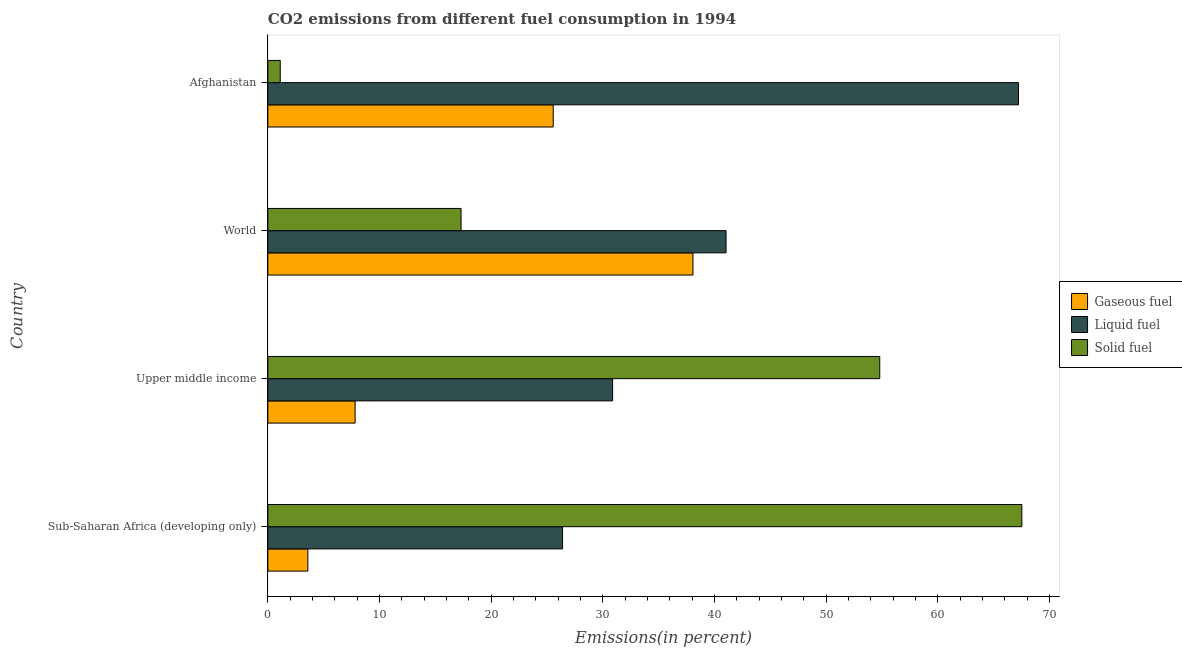How many different coloured bars are there?
Provide a short and direct response. 3. How many bars are there on the 2nd tick from the top?
Keep it short and to the point. 3. What is the label of the 4th group of bars from the top?
Offer a very short reply. Sub-Saharan Africa (developing only). What is the percentage of solid fuel emission in Upper middle income?
Provide a succinct answer. 54.8. Across all countries, what is the maximum percentage of solid fuel emission?
Provide a short and direct response. 67.52. Across all countries, what is the minimum percentage of gaseous fuel emission?
Offer a very short reply. 3.58. In which country was the percentage of liquid fuel emission maximum?
Offer a terse response. Afghanistan. In which country was the percentage of gaseous fuel emission minimum?
Give a very brief answer. Sub-Saharan Africa (developing only). What is the total percentage of gaseous fuel emission in the graph?
Your answer should be very brief. 75.02. What is the difference between the percentage of liquid fuel emission in Afghanistan and that in Sub-Saharan Africa (developing only)?
Your answer should be very brief. 40.83. What is the difference between the percentage of gaseous fuel emission in Sub-Saharan Africa (developing only) and the percentage of solid fuel emission in Afghanistan?
Your response must be concise. 2.47. What is the average percentage of liquid fuel emission per country?
Give a very brief answer. 41.38. What is the difference between the percentage of liquid fuel emission and percentage of gaseous fuel emission in Upper middle income?
Offer a terse response. 23.06. In how many countries, is the percentage of liquid fuel emission greater than 68 %?
Offer a very short reply. 0. What is the ratio of the percentage of gaseous fuel emission in Afghanistan to that in World?
Your answer should be compact. 0.67. Is the percentage of solid fuel emission in Sub-Saharan Africa (developing only) less than that in World?
Keep it short and to the point. No. Is the difference between the percentage of liquid fuel emission in Afghanistan and World greater than the difference between the percentage of gaseous fuel emission in Afghanistan and World?
Offer a very short reply. Yes. What is the difference between the highest and the second highest percentage of solid fuel emission?
Your response must be concise. 12.72. What is the difference between the highest and the lowest percentage of solid fuel emission?
Your answer should be compact. 66.41. In how many countries, is the percentage of gaseous fuel emission greater than the average percentage of gaseous fuel emission taken over all countries?
Ensure brevity in your answer.  2. Is the sum of the percentage of solid fuel emission in Afghanistan and Sub-Saharan Africa (developing only) greater than the maximum percentage of gaseous fuel emission across all countries?
Offer a terse response. Yes. What does the 3rd bar from the top in Upper middle income represents?
Make the answer very short. Gaseous fuel. What does the 3rd bar from the bottom in Upper middle income represents?
Make the answer very short. Solid fuel. Is it the case that in every country, the sum of the percentage of gaseous fuel emission and percentage of liquid fuel emission is greater than the percentage of solid fuel emission?
Make the answer very short. No. Are all the bars in the graph horizontal?
Your response must be concise. Yes. Where does the legend appear in the graph?
Keep it short and to the point. Center right. How many legend labels are there?
Provide a short and direct response. 3. What is the title of the graph?
Your answer should be compact. CO2 emissions from different fuel consumption in 1994. Does "Female employers" appear as one of the legend labels in the graph?
Your response must be concise. No. What is the label or title of the X-axis?
Offer a very short reply. Emissions(in percent). What is the Emissions(in percent) in Gaseous fuel in Sub-Saharan Africa (developing only)?
Offer a terse response. 3.58. What is the Emissions(in percent) in Liquid fuel in Sub-Saharan Africa (developing only)?
Your answer should be very brief. 26.39. What is the Emissions(in percent) in Solid fuel in Sub-Saharan Africa (developing only)?
Your answer should be compact. 67.52. What is the Emissions(in percent) in Gaseous fuel in Upper middle income?
Give a very brief answer. 7.81. What is the Emissions(in percent) of Liquid fuel in Upper middle income?
Ensure brevity in your answer.  30.88. What is the Emissions(in percent) of Solid fuel in Upper middle income?
Provide a succinct answer. 54.8. What is the Emissions(in percent) in Gaseous fuel in World?
Keep it short and to the point. 38.07. What is the Emissions(in percent) of Liquid fuel in World?
Ensure brevity in your answer.  41.03. What is the Emissions(in percent) in Solid fuel in World?
Provide a succinct answer. 17.3. What is the Emissions(in percent) in Gaseous fuel in Afghanistan?
Provide a short and direct response. 25.56. What is the Emissions(in percent) in Liquid fuel in Afghanistan?
Ensure brevity in your answer.  67.22. What is the Emissions(in percent) of Solid fuel in Afghanistan?
Give a very brief answer. 1.11. Across all countries, what is the maximum Emissions(in percent) of Gaseous fuel?
Offer a terse response. 38.07. Across all countries, what is the maximum Emissions(in percent) in Liquid fuel?
Ensure brevity in your answer.  67.22. Across all countries, what is the maximum Emissions(in percent) in Solid fuel?
Make the answer very short. 67.52. Across all countries, what is the minimum Emissions(in percent) in Gaseous fuel?
Offer a very short reply. 3.58. Across all countries, what is the minimum Emissions(in percent) in Liquid fuel?
Your response must be concise. 26.39. Across all countries, what is the minimum Emissions(in percent) in Solid fuel?
Provide a succinct answer. 1.11. What is the total Emissions(in percent) of Gaseous fuel in the graph?
Ensure brevity in your answer.  75.02. What is the total Emissions(in percent) in Liquid fuel in the graph?
Keep it short and to the point. 165.52. What is the total Emissions(in percent) in Solid fuel in the graph?
Your response must be concise. 140.73. What is the difference between the Emissions(in percent) in Gaseous fuel in Sub-Saharan Africa (developing only) and that in Upper middle income?
Your answer should be compact. -4.23. What is the difference between the Emissions(in percent) of Liquid fuel in Sub-Saharan Africa (developing only) and that in Upper middle income?
Provide a succinct answer. -4.48. What is the difference between the Emissions(in percent) in Solid fuel in Sub-Saharan Africa (developing only) and that in Upper middle income?
Provide a short and direct response. 12.72. What is the difference between the Emissions(in percent) in Gaseous fuel in Sub-Saharan Africa (developing only) and that in World?
Keep it short and to the point. -34.49. What is the difference between the Emissions(in percent) of Liquid fuel in Sub-Saharan Africa (developing only) and that in World?
Keep it short and to the point. -14.64. What is the difference between the Emissions(in percent) in Solid fuel in Sub-Saharan Africa (developing only) and that in World?
Provide a short and direct response. 50.22. What is the difference between the Emissions(in percent) of Gaseous fuel in Sub-Saharan Africa (developing only) and that in Afghanistan?
Give a very brief answer. -21.97. What is the difference between the Emissions(in percent) in Liquid fuel in Sub-Saharan Africa (developing only) and that in Afghanistan?
Ensure brevity in your answer.  -40.83. What is the difference between the Emissions(in percent) in Solid fuel in Sub-Saharan Africa (developing only) and that in Afghanistan?
Offer a terse response. 66.41. What is the difference between the Emissions(in percent) of Gaseous fuel in Upper middle income and that in World?
Give a very brief answer. -30.26. What is the difference between the Emissions(in percent) in Liquid fuel in Upper middle income and that in World?
Your answer should be compact. -10.16. What is the difference between the Emissions(in percent) in Solid fuel in Upper middle income and that in World?
Ensure brevity in your answer.  37.49. What is the difference between the Emissions(in percent) of Gaseous fuel in Upper middle income and that in Afghanistan?
Ensure brevity in your answer.  -17.74. What is the difference between the Emissions(in percent) in Liquid fuel in Upper middle income and that in Afghanistan?
Your answer should be compact. -36.35. What is the difference between the Emissions(in percent) of Solid fuel in Upper middle income and that in Afghanistan?
Your response must be concise. 53.69. What is the difference between the Emissions(in percent) of Gaseous fuel in World and that in Afghanistan?
Provide a short and direct response. 12.51. What is the difference between the Emissions(in percent) of Liquid fuel in World and that in Afghanistan?
Give a very brief answer. -26.19. What is the difference between the Emissions(in percent) of Solid fuel in World and that in Afghanistan?
Give a very brief answer. 16.19. What is the difference between the Emissions(in percent) of Gaseous fuel in Sub-Saharan Africa (developing only) and the Emissions(in percent) of Liquid fuel in Upper middle income?
Give a very brief answer. -27.29. What is the difference between the Emissions(in percent) in Gaseous fuel in Sub-Saharan Africa (developing only) and the Emissions(in percent) in Solid fuel in Upper middle income?
Ensure brevity in your answer.  -51.21. What is the difference between the Emissions(in percent) in Liquid fuel in Sub-Saharan Africa (developing only) and the Emissions(in percent) in Solid fuel in Upper middle income?
Keep it short and to the point. -28.41. What is the difference between the Emissions(in percent) in Gaseous fuel in Sub-Saharan Africa (developing only) and the Emissions(in percent) in Liquid fuel in World?
Keep it short and to the point. -37.45. What is the difference between the Emissions(in percent) in Gaseous fuel in Sub-Saharan Africa (developing only) and the Emissions(in percent) in Solid fuel in World?
Offer a very short reply. -13.72. What is the difference between the Emissions(in percent) in Liquid fuel in Sub-Saharan Africa (developing only) and the Emissions(in percent) in Solid fuel in World?
Your answer should be compact. 9.09. What is the difference between the Emissions(in percent) of Gaseous fuel in Sub-Saharan Africa (developing only) and the Emissions(in percent) of Liquid fuel in Afghanistan?
Make the answer very short. -63.64. What is the difference between the Emissions(in percent) of Gaseous fuel in Sub-Saharan Africa (developing only) and the Emissions(in percent) of Solid fuel in Afghanistan?
Provide a succinct answer. 2.47. What is the difference between the Emissions(in percent) of Liquid fuel in Sub-Saharan Africa (developing only) and the Emissions(in percent) of Solid fuel in Afghanistan?
Offer a very short reply. 25.28. What is the difference between the Emissions(in percent) of Gaseous fuel in Upper middle income and the Emissions(in percent) of Liquid fuel in World?
Your response must be concise. -33.22. What is the difference between the Emissions(in percent) in Gaseous fuel in Upper middle income and the Emissions(in percent) in Solid fuel in World?
Ensure brevity in your answer.  -9.49. What is the difference between the Emissions(in percent) in Liquid fuel in Upper middle income and the Emissions(in percent) in Solid fuel in World?
Provide a succinct answer. 13.57. What is the difference between the Emissions(in percent) in Gaseous fuel in Upper middle income and the Emissions(in percent) in Liquid fuel in Afghanistan?
Your response must be concise. -59.41. What is the difference between the Emissions(in percent) of Gaseous fuel in Upper middle income and the Emissions(in percent) of Solid fuel in Afghanistan?
Provide a short and direct response. 6.7. What is the difference between the Emissions(in percent) of Liquid fuel in Upper middle income and the Emissions(in percent) of Solid fuel in Afghanistan?
Ensure brevity in your answer.  29.76. What is the difference between the Emissions(in percent) of Gaseous fuel in World and the Emissions(in percent) of Liquid fuel in Afghanistan?
Offer a very short reply. -29.15. What is the difference between the Emissions(in percent) of Gaseous fuel in World and the Emissions(in percent) of Solid fuel in Afghanistan?
Make the answer very short. 36.96. What is the difference between the Emissions(in percent) in Liquid fuel in World and the Emissions(in percent) in Solid fuel in Afghanistan?
Provide a short and direct response. 39.92. What is the average Emissions(in percent) of Gaseous fuel per country?
Ensure brevity in your answer.  18.76. What is the average Emissions(in percent) in Liquid fuel per country?
Provide a succinct answer. 41.38. What is the average Emissions(in percent) in Solid fuel per country?
Offer a terse response. 35.18. What is the difference between the Emissions(in percent) in Gaseous fuel and Emissions(in percent) in Liquid fuel in Sub-Saharan Africa (developing only)?
Ensure brevity in your answer.  -22.81. What is the difference between the Emissions(in percent) of Gaseous fuel and Emissions(in percent) of Solid fuel in Sub-Saharan Africa (developing only)?
Your answer should be compact. -63.94. What is the difference between the Emissions(in percent) of Liquid fuel and Emissions(in percent) of Solid fuel in Sub-Saharan Africa (developing only)?
Provide a short and direct response. -41.13. What is the difference between the Emissions(in percent) of Gaseous fuel and Emissions(in percent) of Liquid fuel in Upper middle income?
Offer a terse response. -23.06. What is the difference between the Emissions(in percent) in Gaseous fuel and Emissions(in percent) in Solid fuel in Upper middle income?
Make the answer very short. -46.98. What is the difference between the Emissions(in percent) of Liquid fuel and Emissions(in percent) of Solid fuel in Upper middle income?
Your answer should be very brief. -23.92. What is the difference between the Emissions(in percent) in Gaseous fuel and Emissions(in percent) in Liquid fuel in World?
Provide a succinct answer. -2.96. What is the difference between the Emissions(in percent) in Gaseous fuel and Emissions(in percent) in Solid fuel in World?
Give a very brief answer. 20.77. What is the difference between the Emissions(in percent) of Liquid fuel and Emissions(in percent) of Solid fuel in World?
Provide a succinct answer. 23.73. What is the difference between the Emissions(in percent) of Gaseous fuel and Emissions(in percent) of Liquid fuel in Afghanistan?
Provide a short and direct response. -41.67. What is the difference between the Emissions(in percent) of Gaseous fuel and Emissions(in percent) of Solid fuel in Afghanistan?
Your answer should be compact. 24.44. What is the difference between the Emissions(in percent) in Liquid fuel and Emissions(in percent) in Solid fuel in Afghanistan?
Keep it short and to the point. 66.11. What is the ratio of the Emissions(in percent) in Gaseous fuel in Sub-Saharan Africa (developing only) to that in Upper middle income?
Your answer should be very brief. 0.46. What is the ratio of the Emissions(in percent) of Liquid fuel in Sub-Saharan Africa (developing only) to that in Upper middle income?
Offer a terse response. 0.85. What is the ratio of the Emissions(in percent) in Solid fuel in Sub-Saharan Africa (developing only) to that in Upper middle income?
Keep it short and to the point. 1.23. What is the ratio of the Emissions(in percent) in Gaseous fuel in Sub-Saharan Africa (developing only) to that in World?
Keep it short and to the point. 0.09. What is the ratio of the Emissions(in percent) in Liquid fuel in Sub-Saharan Africa (developing only) to that in World?
Give a very brief answer. 0.64. What is the ratio of the Emissions(in percent) in Solid fuel in Sub-Saharan Africa (developing only) to that in World?
Provide a short and direct response. 3.9. What is the ratio of the Emissions(in percent) in Gaseous fuel in Sub-Saharan Africa (developing only) to that in Afghanistan?
Ensure brevity in your answer.  0.14. What is the ratio of the Emissions(in percent) in Liquid fuel in Sub-Saharan Africa (developing only) to that in Afghanistan?
Offer a terse response. 0.39. What is the ratio of the Emissions(in percent) in Solid fuel in Sub-Saharan Africa (developing only) to that in Afghanistan?
Ensure brevity in your answer.  60.77. What is the ratio of the Emissions(in percent) of Gaseous fuel in Upper middle income to that in World?
Offer a terse response. 0.21. What is the ratio of the Emissions(in percent) in Liquid fuel in Upper middle income to that in World?
Offer a terse response. 0.75. What is the ratio of the Emissions(in percent) in Solid fuel in Upper middle income to that in World?
Your answer should be compact. 3.17. What is the ratio of the Emissions(in percent) in Gaseous fuel in Upper middle income to that in Afghanistan?
Provide a short and direct response. 0.31. What is the ratio of the Emissions(in percent) in Liquid fuel in Upper middle income to that in Afghanistan?
Offer a terse response. 0.46. What is the ratio of the Emissions(in percent) in Solid fuel in Upper middle income to that in Afghanistan?
Keep it short and to the point. 49.32. What is the ratio of the Emissions(in percent) in Gaseous fuel in World to that in Afghanistan?
Offer a very short reply. 1.49. What is the ratio of the Emissions(in percent) in Liquid fuel in World to that in Afghanistan?
Provide a short and direct response. 0.61. What is the ratio of the Emissions(in percent) in Solid fuel in World to that in Afghanistan?
Offer a very short reply. 15.57. What is the difference between the highest and the second highest Emissions(in percent) of Gaseous fuel?
Keep it short and to the point. 12.51. What is the difference between the highest and the second highest Emissions(in percent) in Liquid fuel?
Provide a short and direct response. 26.19. What is the difference between the highest and the second highest Emissions(in percent) in Solid fuel?
Keep it short and to the point. 12.72. What is the difference between the highest and the lowest Emissions(in percent) of Gaseous fuel?
Your answer should be very brief. 34.49. What is the difference between the highest and the lowest Emissions(in percent) in Liquid fuel?
Your answer should be very brief. 40.83. What is the difference between the highest and the lowest Emissions(in percent) in Solid fuel?
Make the answer very short. 66.41. 